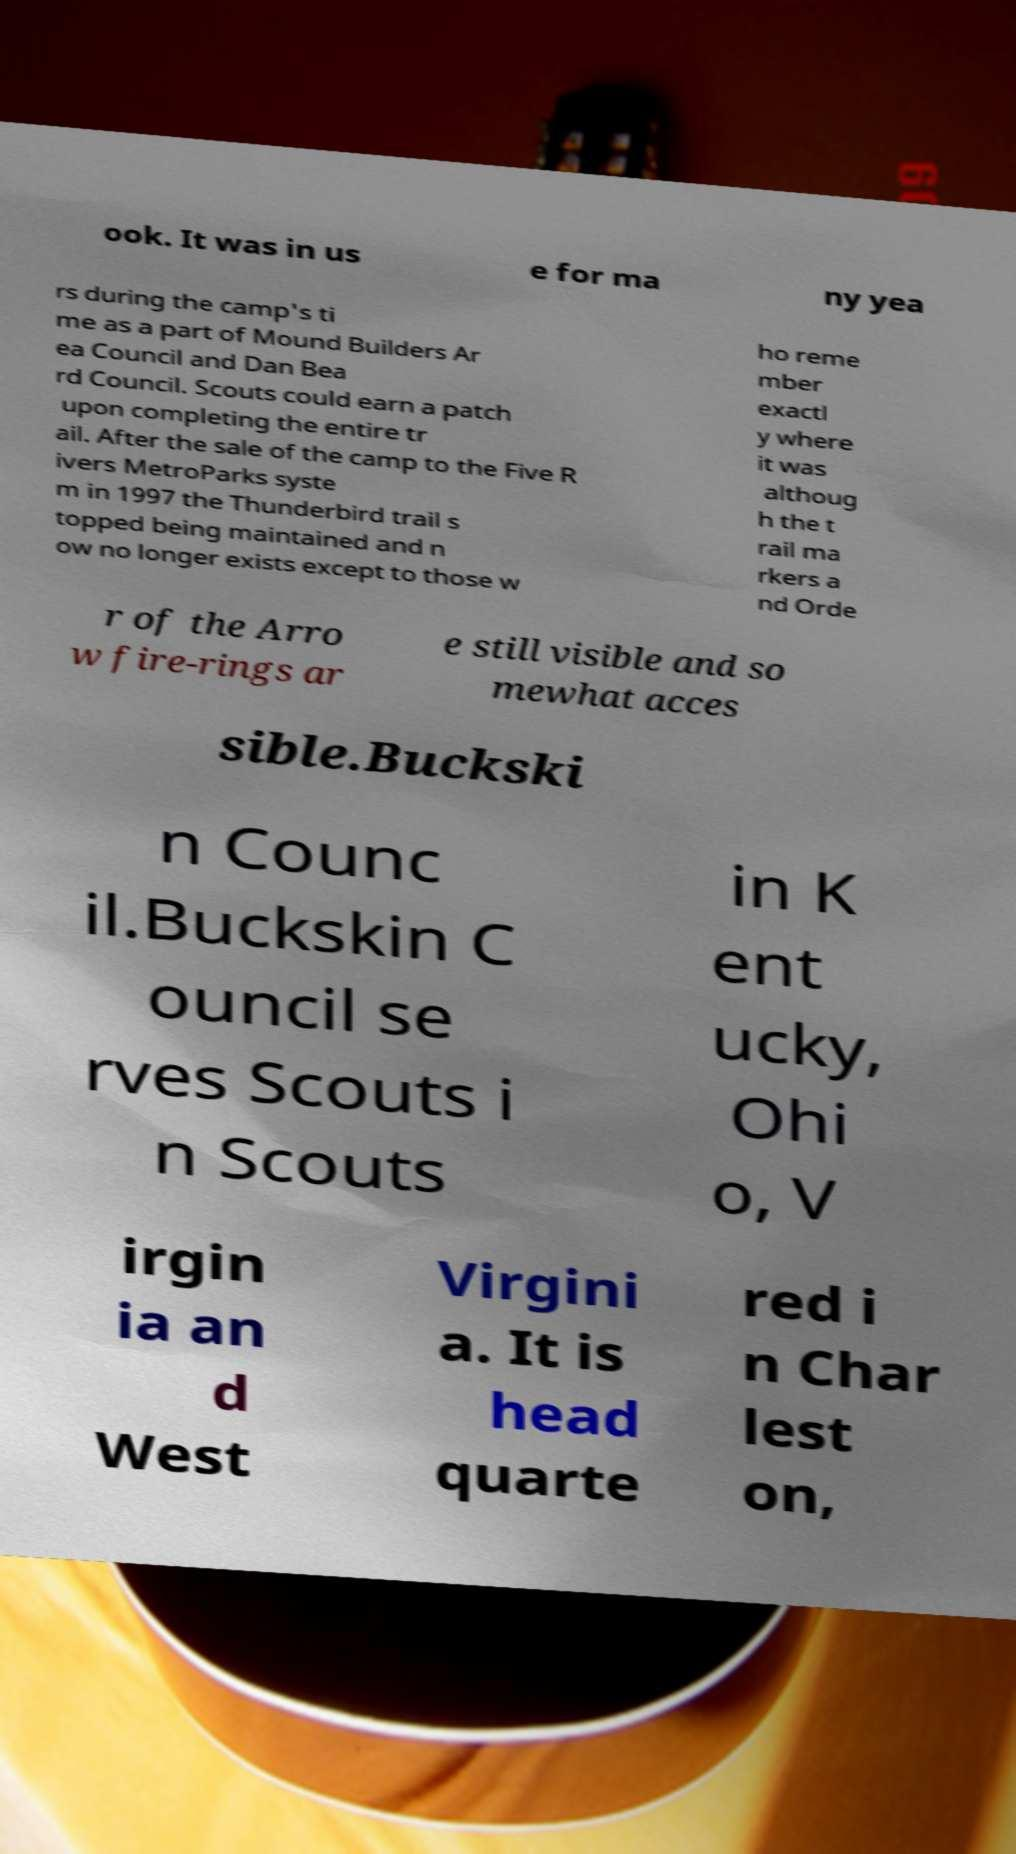I need the written content from this picture converted into text. Can you do that? ook. It was in us e for ma ny yea rs during the camp's ti me as a part of Mound Builders Ar ea Council and Dan Bea rd Council. Scouts could earn a patch upon completing the entire tr ail. After the sale of the camp to the Five R ivers MetroParks syste m in 1997 the Thunderbird trail s topped being maintained and n ow no longer exists except to those w ho reme mber exactl y where it was althoug h the t rail ma rkers a nd Orde r of the Arro w fire-rings ar e still visible and so mewhat acces sible.Buckski n Counc il.Buckskin C ouncil se rves Scouts i n Scouts in K ent ucky, Ohi o, V irgin ia an d West Virgini a. It is head quarte red i n Char lest on, 